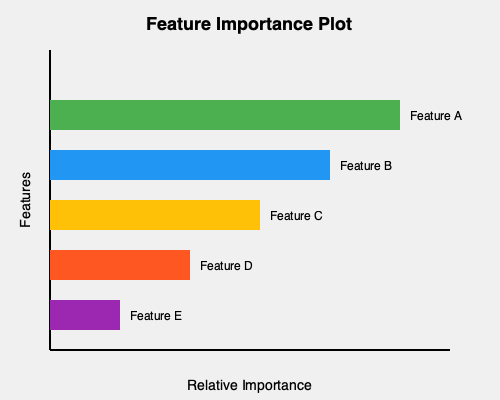Based on the feature importance plot generated by an H2O random forest model, which feature appears to have the highest relative importance, and what does this imply about its impact on the model's predictions? To interpret the feature importance plot from an H2O random forest model, we need to follow these steps:

1. Understand the plot: The horizontal bars represent the relative importance of each feature in the model. Longer bars indicate higher importance.

2. Identify the features: The plot shows five features (A, B, C, D, and E) with varying bar lengths.

3. Compare bar lengths: Feature A has the longest bar, followed by B, C, D, and E in descending order.

4. Interpret relative importance: The length of each bar represents the feature's contribution to the model's predictive power. A longer bar means the feature has a greater impact on the model's decisions.

5. Analyze Feature A: As it has the longest bar, Feature A is the most important feature in this random forest model.

6. Understand the implication: The high importance of Feature A suggests that:
   a) It has the strongest predictive power among all features.
   b) Changes in Feature A are likely to have the most significant impact on the model's predictions.
   c) The model relies heavily on Feature A when making decisions.

7. Consider model behavior: When Feature A changes, we can expect larger changes in the model's output compared to changes in other features.

8. Note on interpretation: While Feature A is most important, other features still contribute to the model's predictions, especially B and C, which also have relatively long bars.
Answer: Feature A has the highest relative importance, implying it has the strongest influence on the model's predictions. 